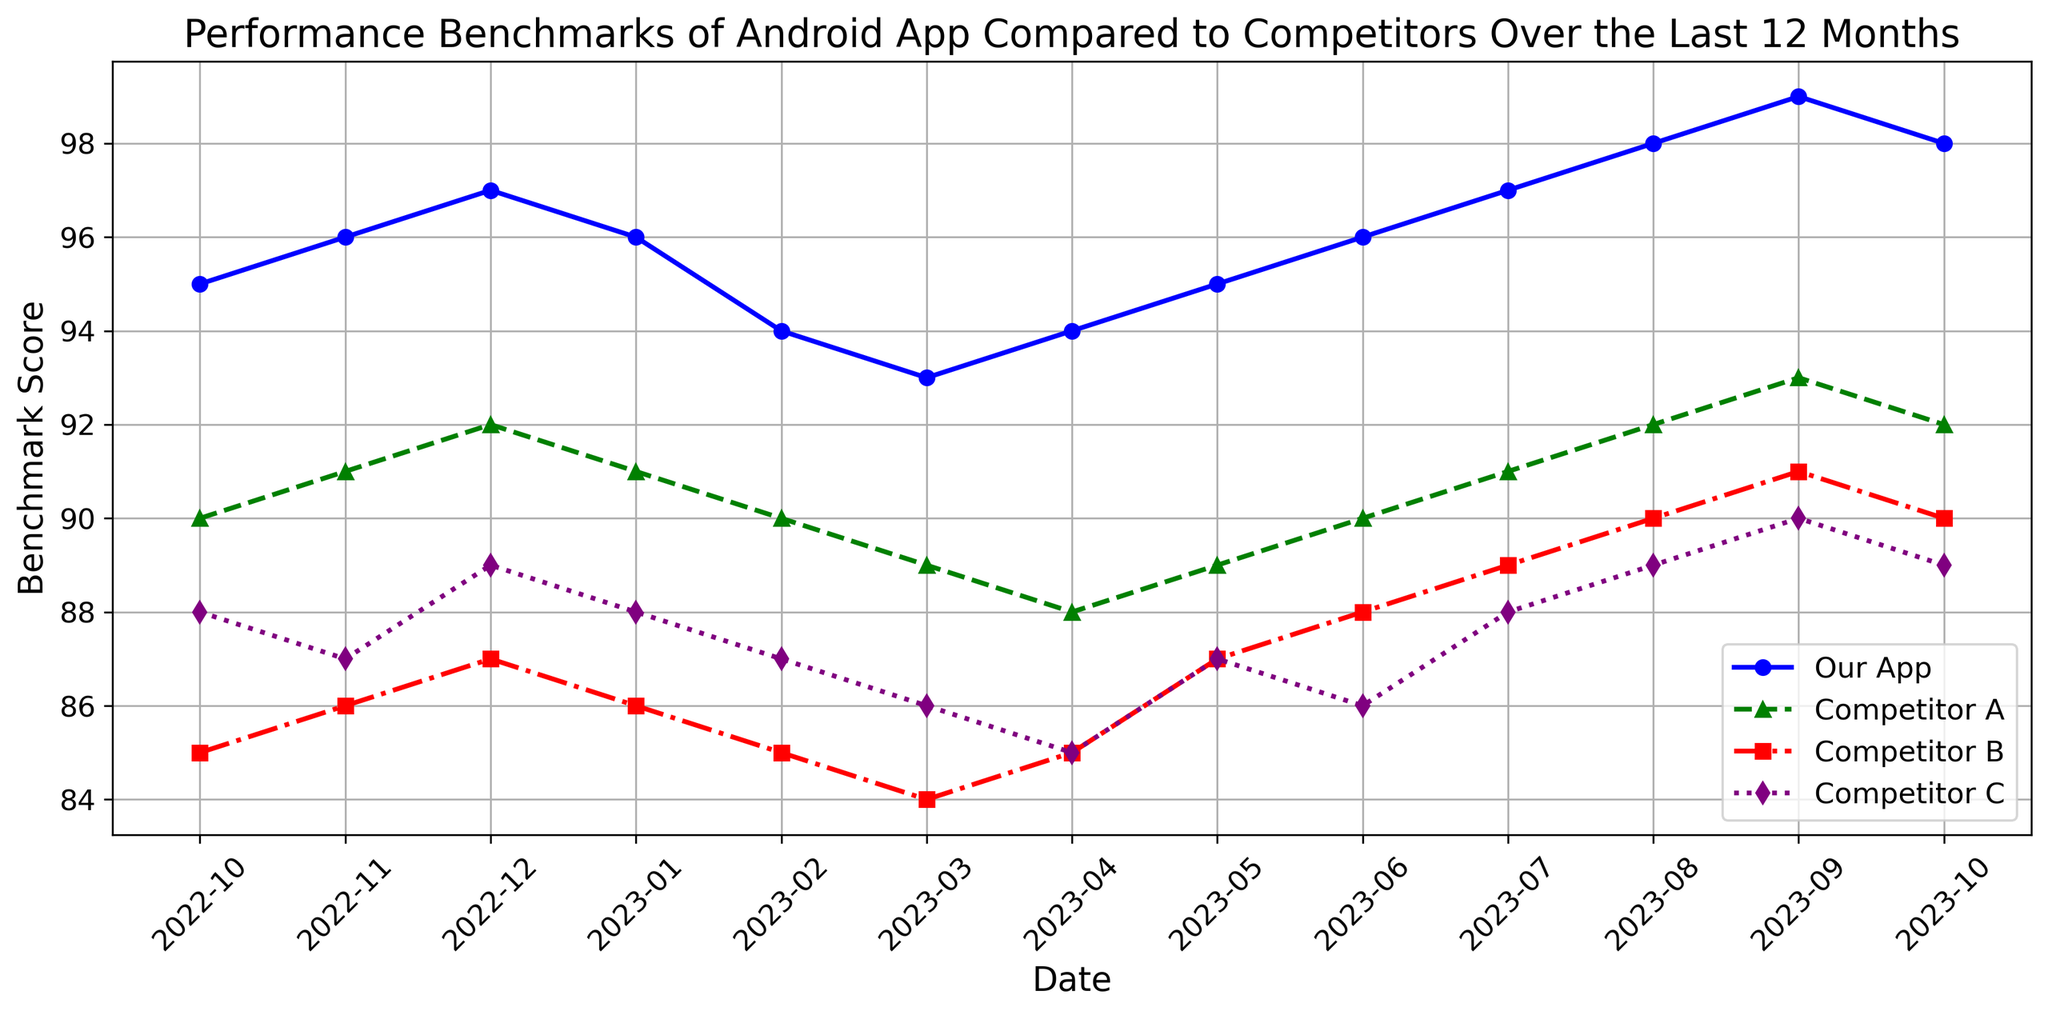What's the pattern of performance for Our App over the last 12 months? Observe the blue line with circles representing Our App. It generally shows an upward trend starting from 95 in October 2022 and peaking at 99 in September 2023 before slightly declining to 98 in October 2023.
Answer: Upward trend Which month shows the highest performance benchmark for Competitor B? Follow the red line with squares representing Competitor B. The highest point on this line is observed in September 2023 at 91.
Answer: September 2023 How does Our App’s performance in December 2022 compare to Competitor A’s performance in the same month? Our App (blue line) has a score of 97 in December 2022, while Competitor A (green line) has a score of 92 in the same month. Therefore, Our App outperforms Competitor A.
Answer: Our App is higher What is the average performance benchmark for Competitor C over the 12 months? Add up the performance scores for each month for Competitor C (88 + 87 + 89 + 88 + 87 + 86 + 85 + 87 + 86 + 88 + 89 + 90 + 89) which sums to 1050 and divide by 12. The average is 1050 / 12 = 87.5.
Answer: 87.5 During which months does Competitor A outperform Competitor B? Compare the green and red lines. Competitor A outperforms Competitor B in October 2022, November 2022, December 2022, January 2023, February 2023, March 2023, April 2023, June 2023, August 2023, and October 2023.
Answer: 10 months In which months does Our App have a lower performance than in the previous month? Identify the decreases in the blue line. From December 2022 to January 2023 (97 to 96), February 2023 (96 to 94), March 2023 (94 to 93), and from September 2023 to October 2023 (99 to 98).
Answer: January, February, March, October 2023 What is the difference in performance between Our App and Competitor C in September 2023? In September 2023, the blue line for Our App is at 99, while the purple line for Competitor C is at 90. The difference is 99 - 90 = 9.
Answer: 9 points Identify the months where all competitors (A, B, C) performed worse than Our App. Compare the blue line to all other lines for each month. The months are October 2022, November 2022, December 2022, May 2023, June 2023, July 2023, August 2023, September 2023, and October 2023.
Answer: 9 months 